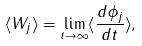Convert formula to latex. <formula><loc_0><loc_0><loc_500><loc_500>\langle W _ { j } \rangle = \lim _ { t \rightarrow \infty } \langle \frac { d \phi _ { j } } { d t } \rangle ,</formula> 